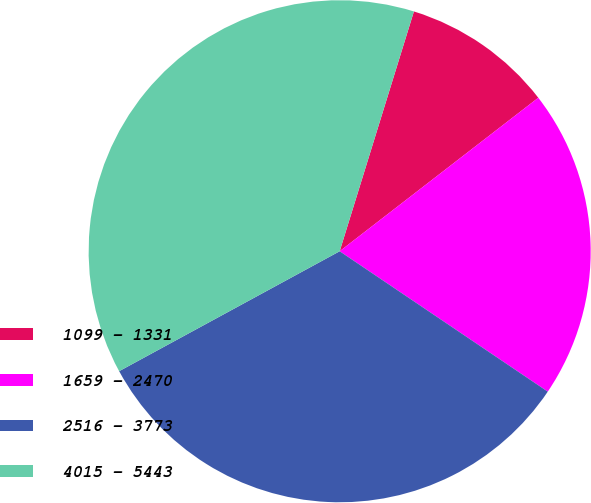<chart> <loc_0><loc_0><loc_500><loc_500><pie_chart><fcel>1099 - 1331<fcel>1659 - 2470<fcel>2516 - 3773<fcel>4015 - 5443<nl><fcel>9.75%<fcel>19.92%<fcel>32.63%<fcel>37.71%<nl></chart> 